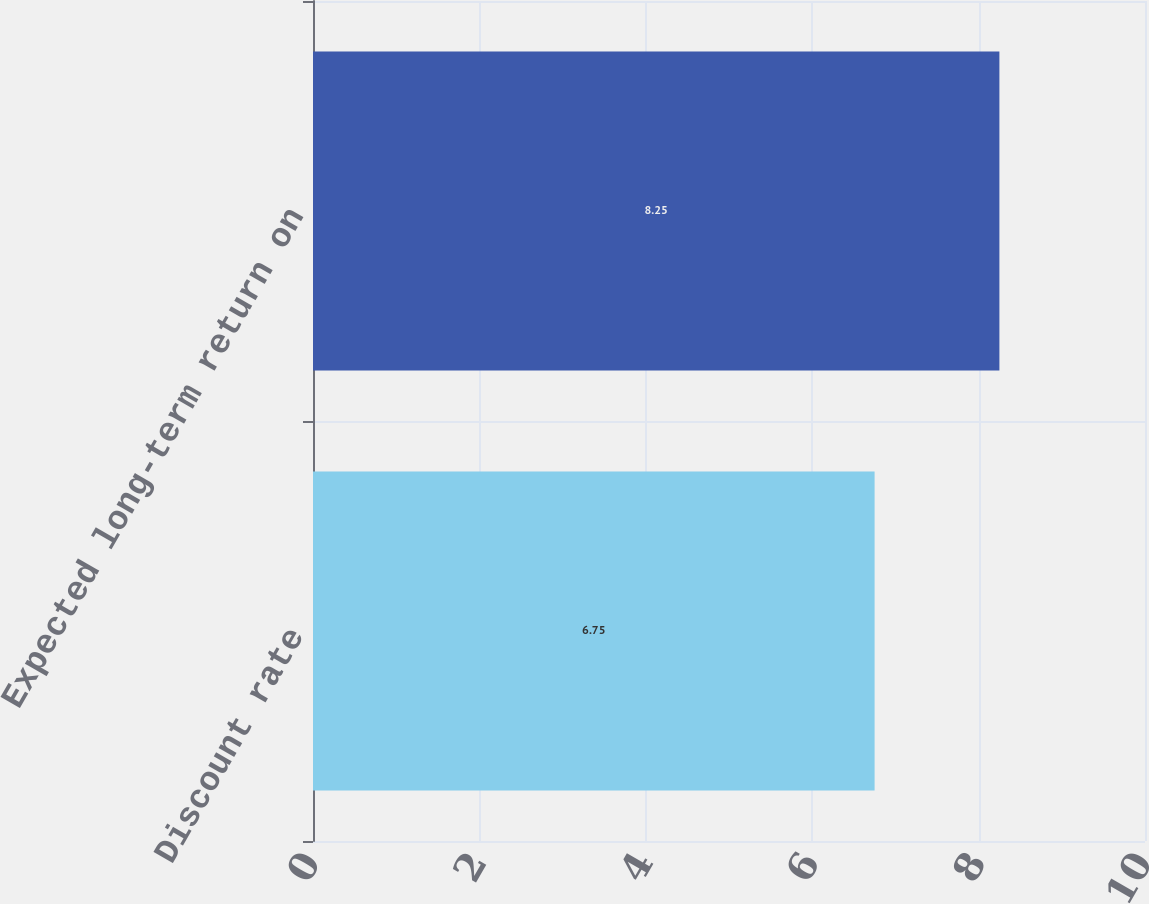<chart> <loc_0><loc_0><loc_500><loc_500><bar_chart><fcel>Discount rate<fcel>Expected long-term return on<nl><fcel>6.75<fcel>8.25<nl></chart> 